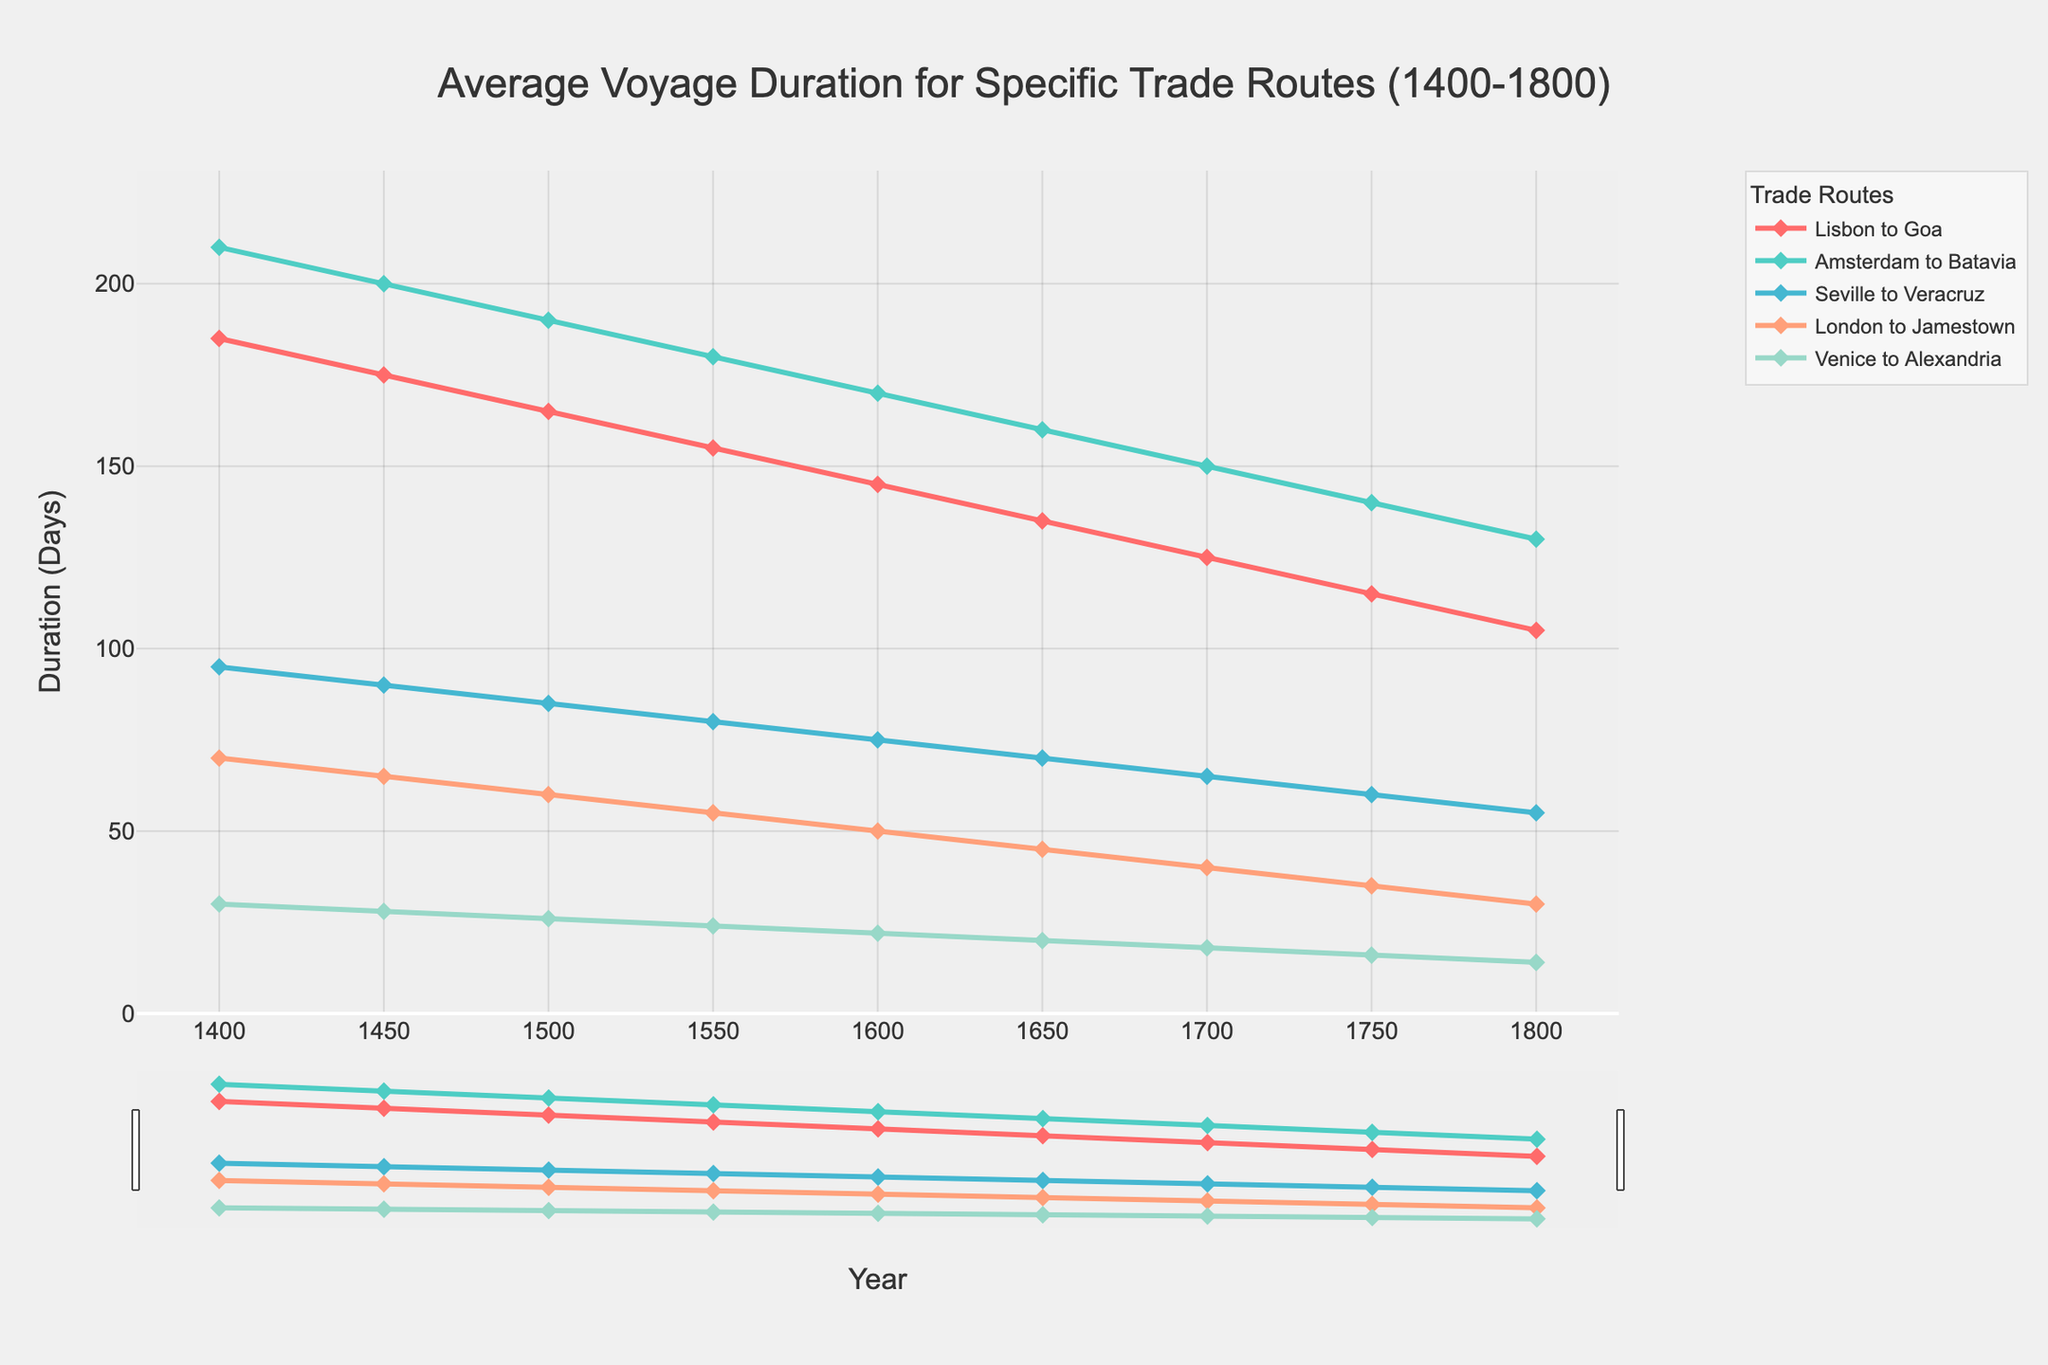What is the duration difference between the Lisbon to Goa route and the Venice to Alexandria route in the year 1400? The duration for Lisbon to Goa in 1400 is 185 days and for Venice to Alexandria is 30 days. Subtract the latter from the former: 185 - 30 = 155 days.
Answer: 155 days Which trade route showed the greatest decrease in voyage duration from 1400 to 1800? Compare the duration decrease for all routes between 1400 and 1800. The largest decrease is for Lisbon to Goa, from 185 days to 105 days.
Answer: Lisbon to Goa How does the average duration of the Seville to Veracruz route in 1600 compare to the Amsterdam to Batavia route in the same year? In 1600, Seville to Veracruz has a duration of 75 days, while Amsterdam to Batavia has a duration of 170 days. The Amsterdam to Batavia route is longer.
Answer: Amsterdam to Batavia is longer What is the overall trend in voyage duration for the London to Jamestown route from 1400 to 1800? Observe the line for London to Jamestown. It consistently decreases from 70 days in 1400 to 30 days in 1800.
Answer: Decreasing trend Identify the year when the Venice to Alexandria route first drops below 20 days. Check the line for Venice to Alexandria. It first drops below 20 days in the year 1650 and continues to decrease.
Answer: 1650 Comparing the voyage durations in 1750, which route had the shortest duration, and what was it? Look at the values for 1750. The Venice to Alexandria route has the shortest duration at 16 days.
Answer: Venice to Alexandria, 16 days What can be inferred about the speed improvements in sailing technology between 1400 and 1800 based on the data? Analyze the general trend for all routes. Each route shows a significant reduction in voyage duration over the 400 years, indicating substantial improvements in sailing efficiency and speed.
Answer: Significant improvements in speed How does the duration change for the Amsterdam to Batavia route between 1500 and 1700? In 1500, the duration is 190 days, and in 1700, it is 150 days. The decrease is 190 - 150 = 40 days.
Answer: Decrease by 40 days What is the combined duration for the Seville to Veracruz and London to Jamestown routes in the year 1550? In 1550, the Seville to Veracruz duration is 80 days and the London to Jamestown duration is 55 days. The combined duration is 80 + 55 = 135 days.
Answer: 135 days Observing the color and line style, what color is used for the Lisbon to Goa route, and how are the data points marked? The Lisbon to Goa route is depicted in red and marked with diamond-shaped markers.
Answer: Red with diamond markers 